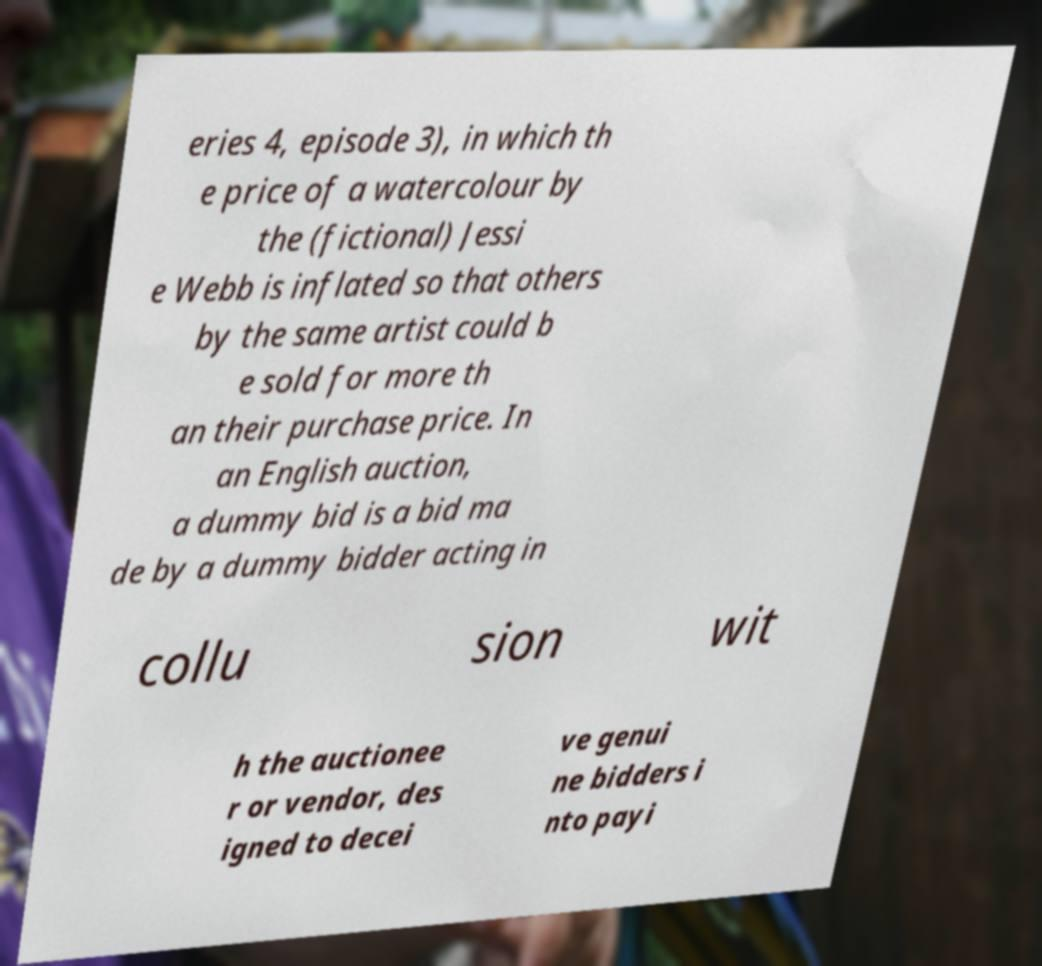Could you assist in decoding the text presented in this image and type it out clearly? eries 4, episode 3), in which th e price of a watercolour by the (fictional) Jessi e Webb is inflated so that others by the same artist could b e sold for more th an their purchase price. In an English auction, a dummy bid is a bid ma de by a dummy bidder acting in collu sion wit h the auctionee r or vendor, des igned to decei ve genui ne bidders i nto payi 